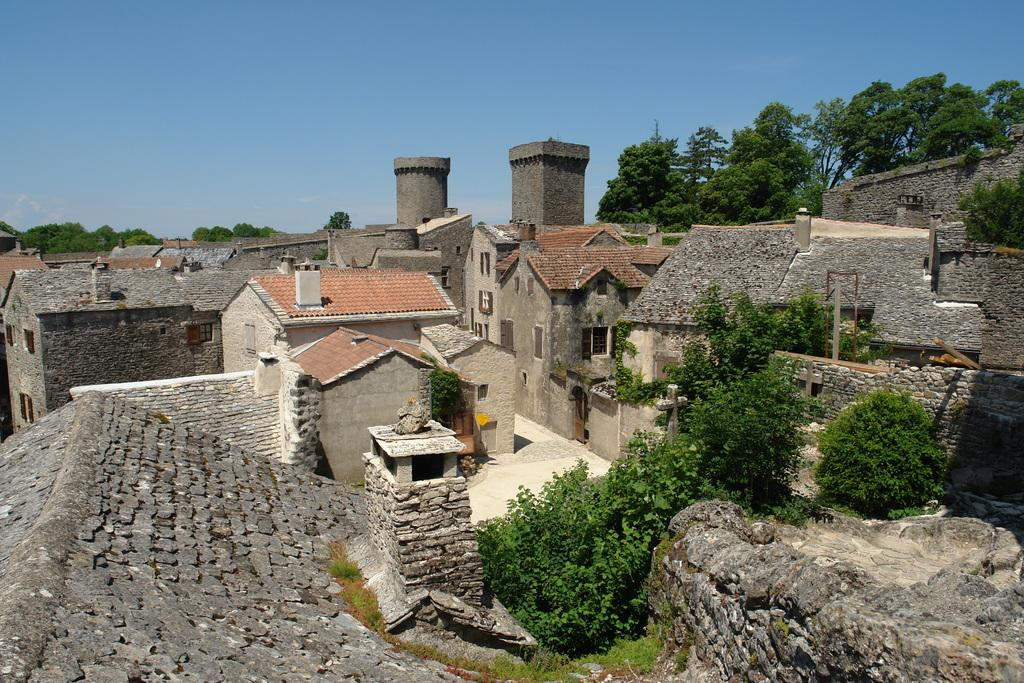What type of structures can be seen in the image? There are houses in the image. What type of vegetation is present in the image? There are trees in the image. What is the tendency of the egg in the image? There is no egg present in the image, so it is not possible to determine its tendency. What type of approval is being given in the image? There is no indication of any approval being given in the image. 